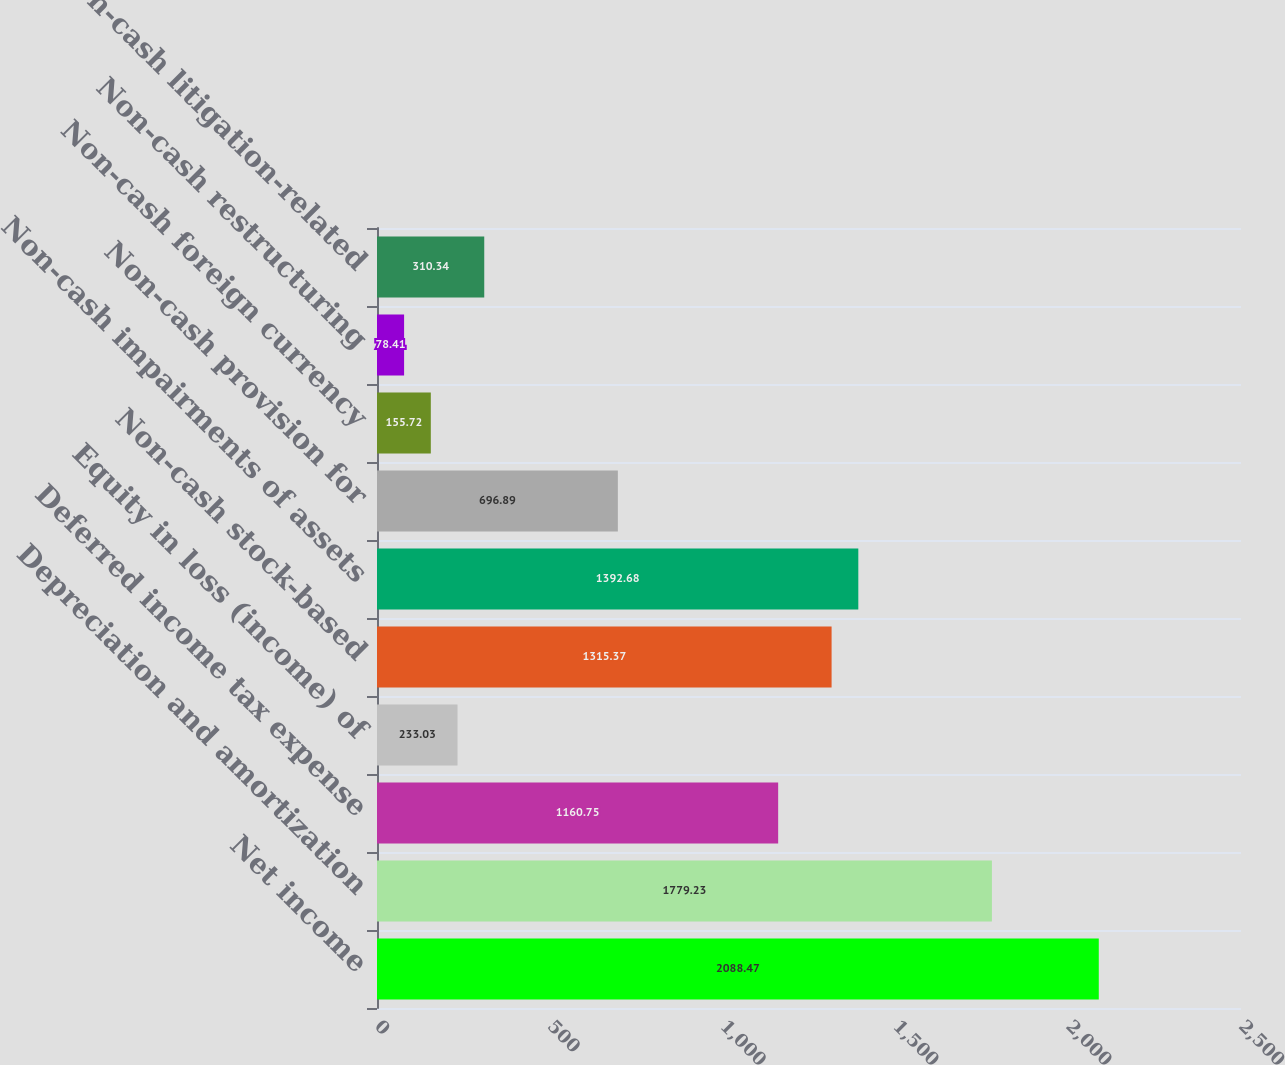<chart> <loc_0><loc_0><loc_500><loc_500><bar_chart><fcel>Net income<fcel>Depreciation and amortization<fcel>Deferred income tax expense<fcel>Equity in loss (income) of<fcel>Non-cash stock-based<fcel>Non-cash impairments of assets<fcel>Non-cash provision for<fcel>Non-cash foreign currency<fcel>Non-cash restructuring<fcel>Non-cash litigation-related<nl><fcel>2088.47<fcel>1779.23<fcel>1160.75<fcel>233.03<fcel>1315.37<fcel>1392.68<fcel>696.89<fcel>155.72<fcel>78.41<fcel>310.34<nl></chart> 